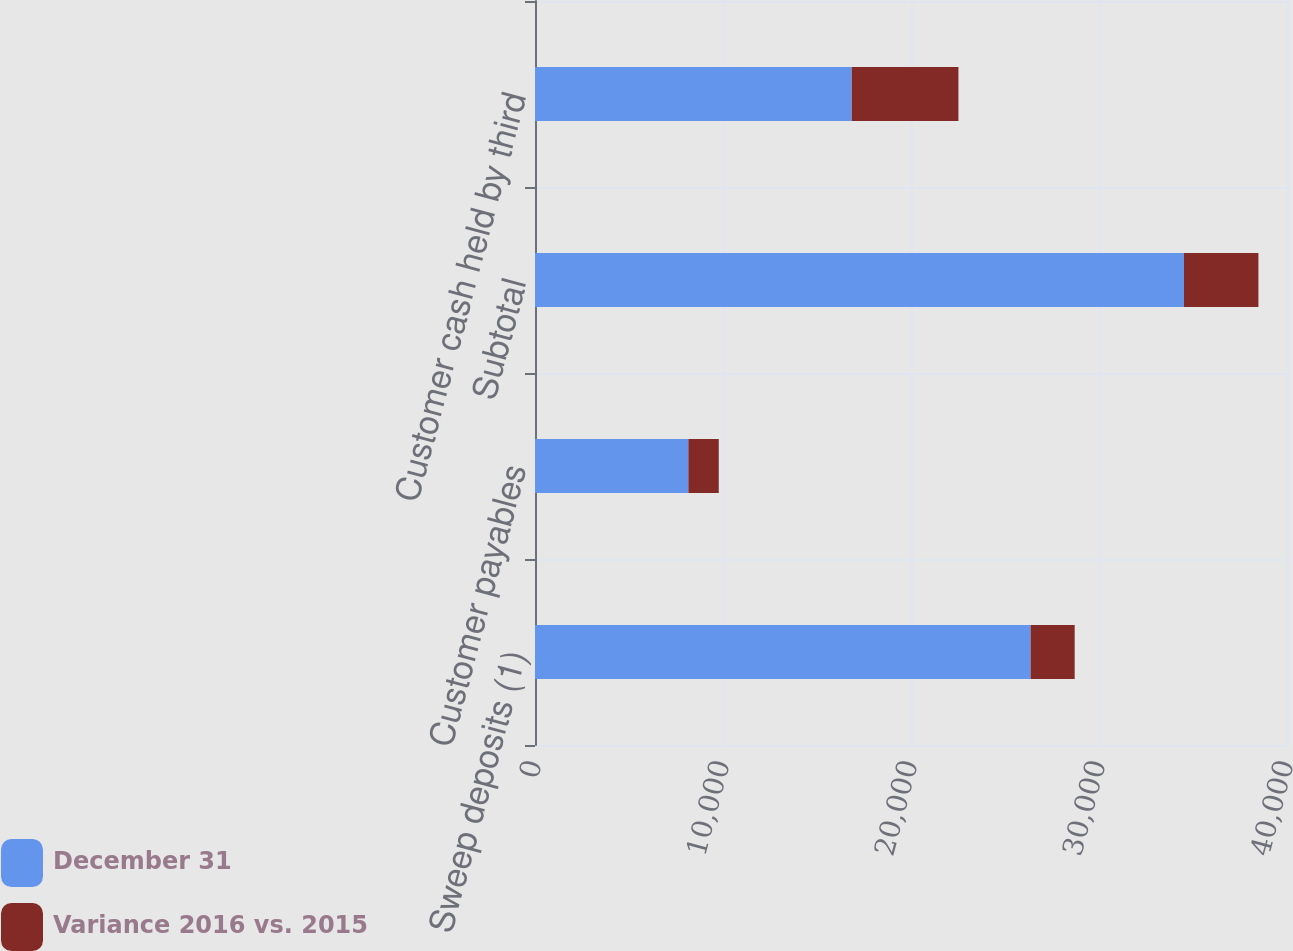Convert chart. <chart><loc_0><loc_0><loc_500><loc_500><stacked_bar_chart><ecel><fcel>Sweep deposits (1)<fcel>Customer payables<fcel>Subtotal<fcel>Customer cash held by third<nl><fcel>December 31<fcel>26362<fcel>8159<fcel>34521<fcel>16848<nl><fcel>Variance 2016 vs. 2015<fcel>2344<fcel>1615<fcel>3959<fcel>5675<nl></chart> 